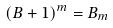Convert formula to latex. <formula><loc_0><loc_0><loc_500><loc_500>( B + 1 ) ^ { m } = B _ { m }</formula> 